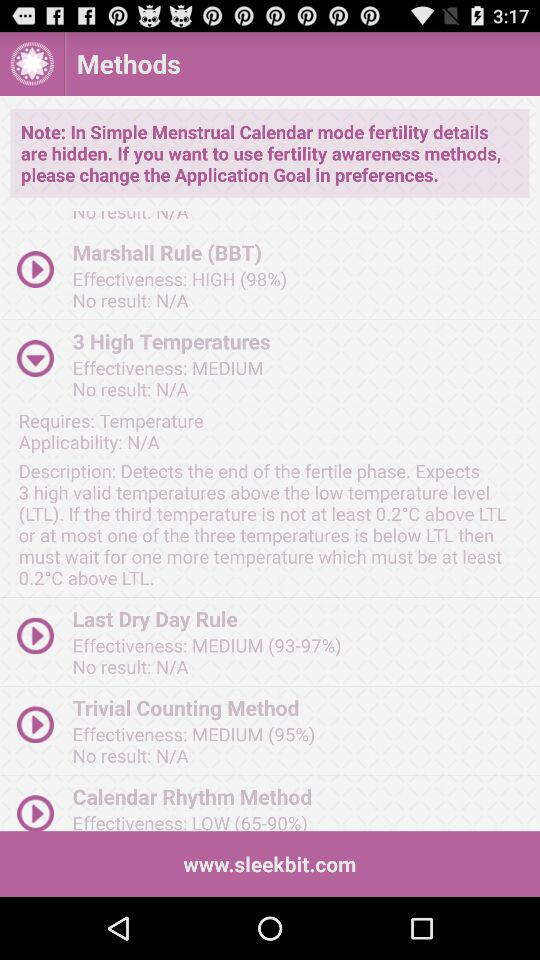What is the effectiveness of the Marshall rule? The effectiveness is high (98%). 